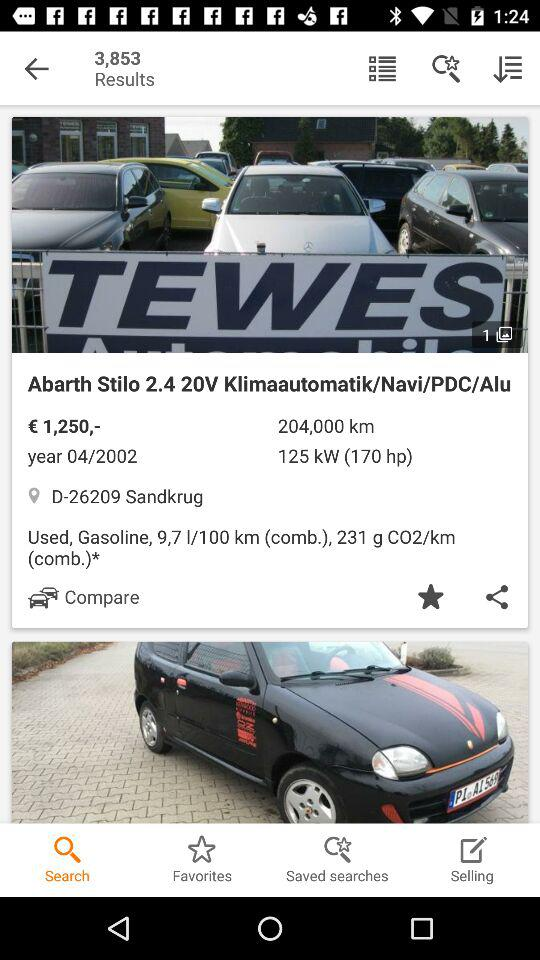What is the price? The price is € 1,250. 